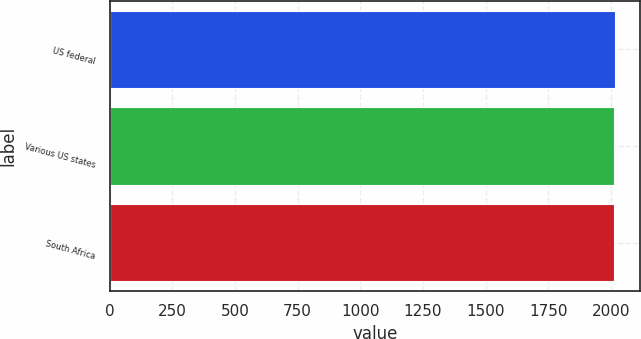Convert chart. <chart><loc_0><loc_0><loc_500><loc_500><bar_chart><fcel>US federal<fcel>Various US states<fcel>South Africa<nl><fcel>2014<fcel>2010<fcel>2010.4<nl></chart> 